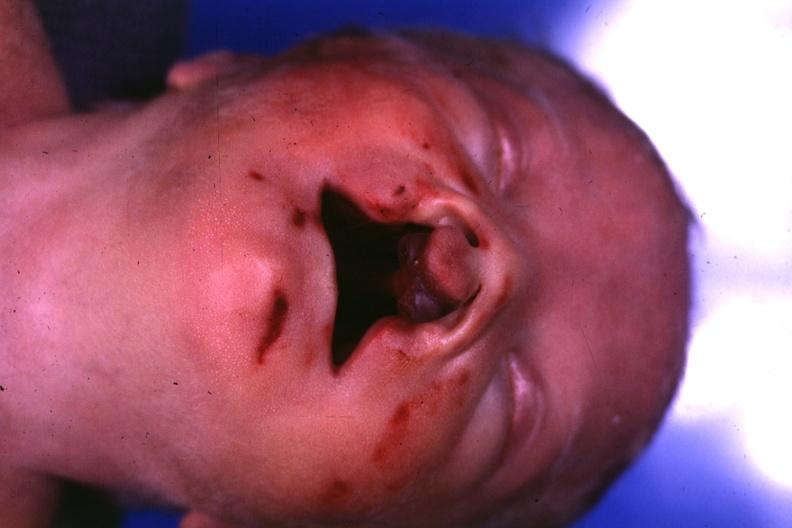s face present?
Answer the question using a single word or phrase. Yes 